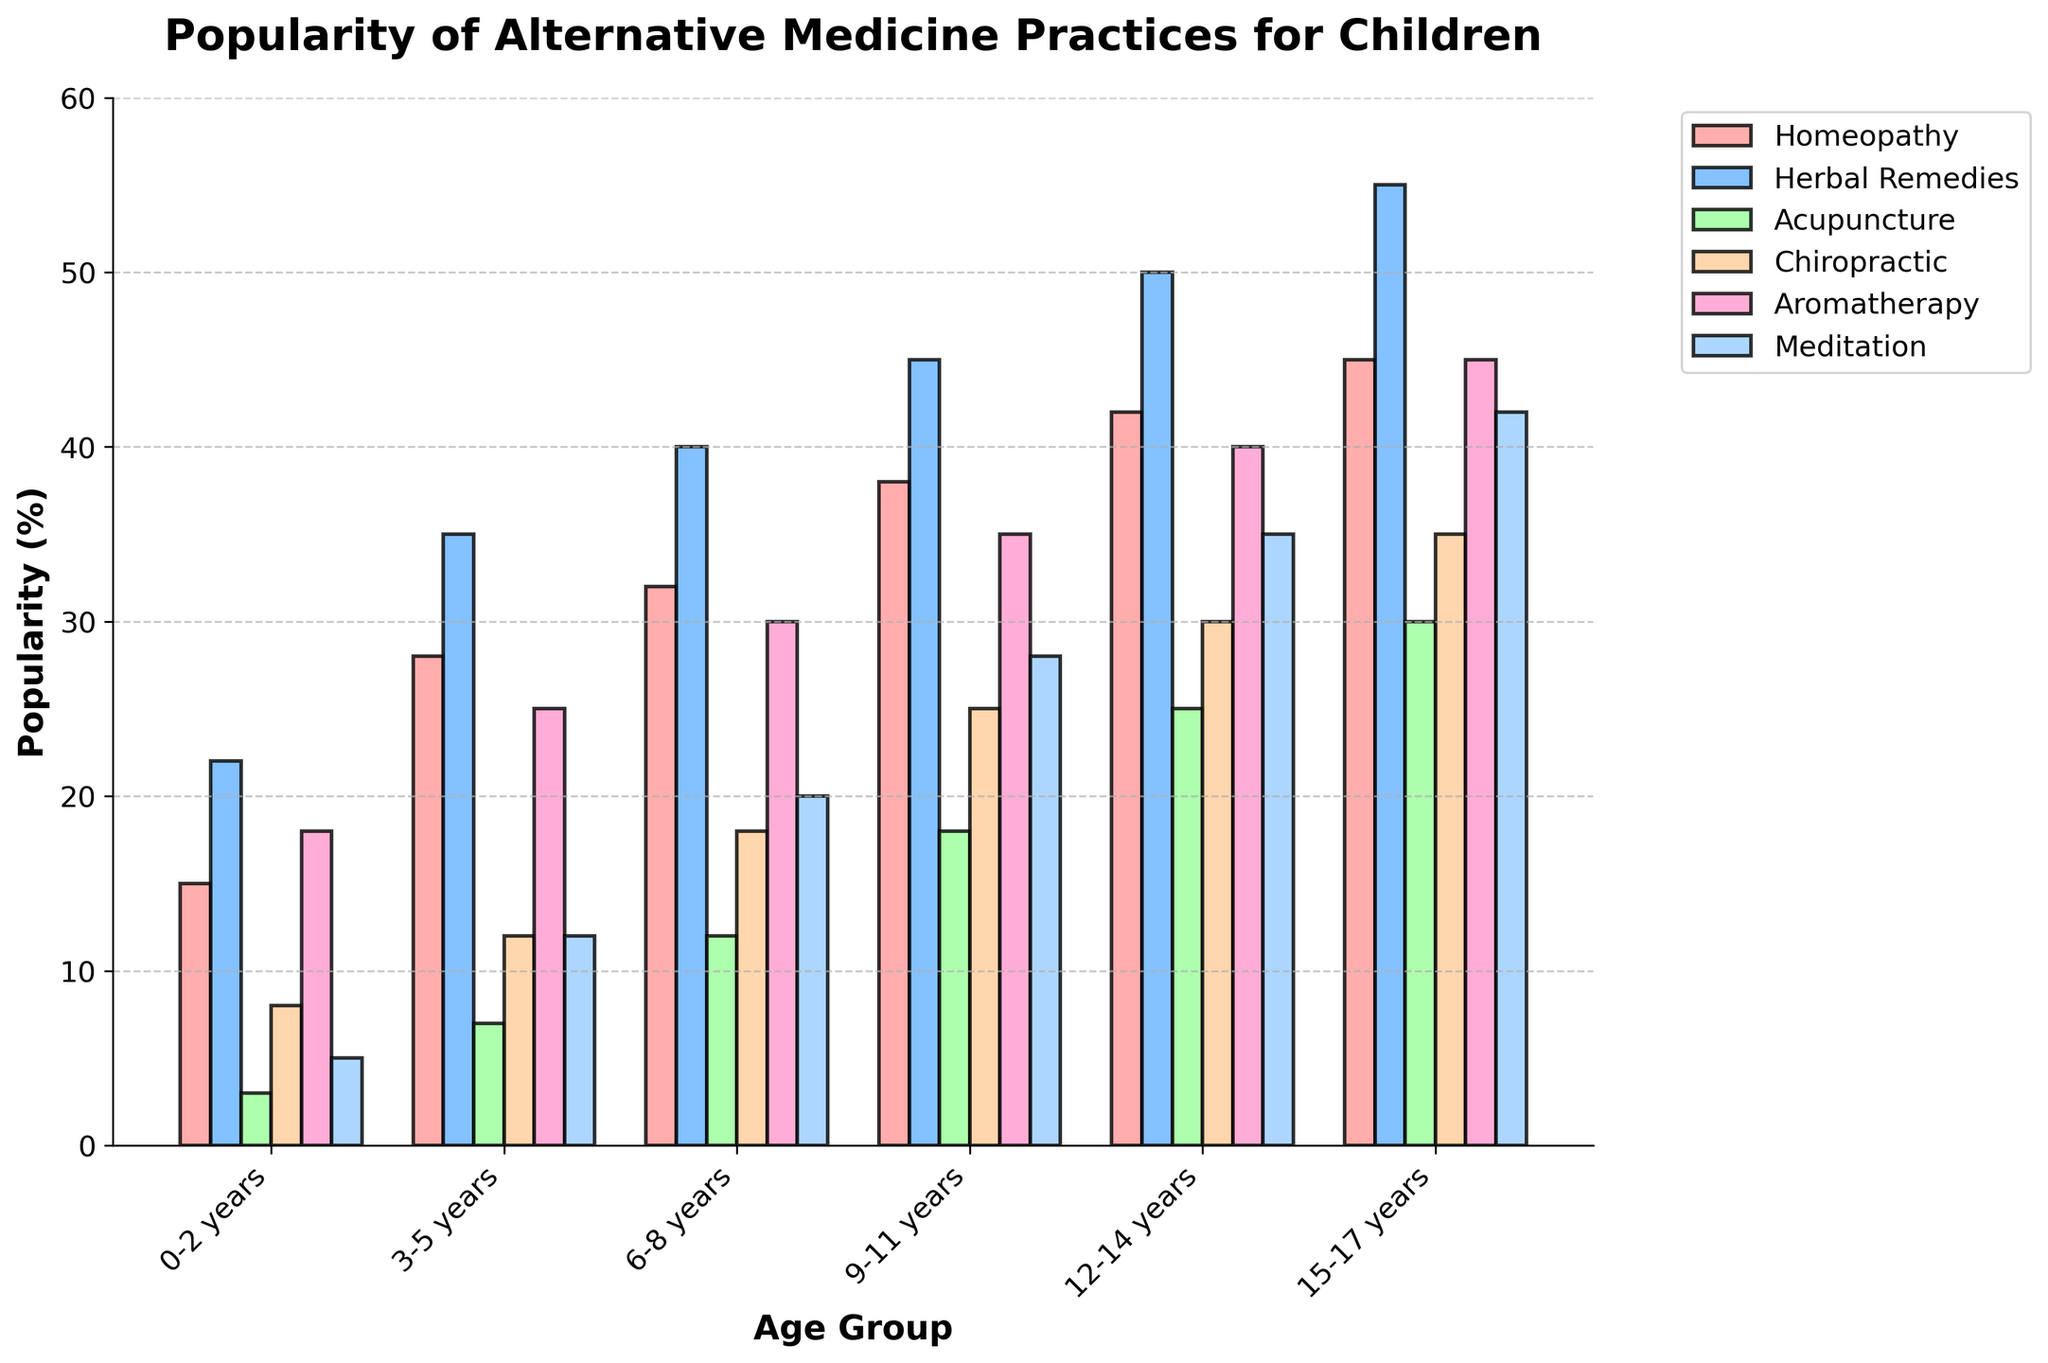Which alternative medicine practice is the most popular for children aged 15-17 years? Look at the height of the bars for the 15-17 years age group. The bar for Herbal Remedies is the highest.
Answer: Herbal Remedies How does the popularity of Acupuncture for children aged 6-8 years compare with those aged 0-2 years? Compare the height of the bars for Acupuncture in the age groups 6-8 years and 0-2 years. The value for 6-8 years is higher than 0-2 years.
Answer: Higher What is the total popularity percentage of Homeopathy and Aromatherapy combined for children aged 9-11 years? Sum the values for Homeopathy and Aromatherapy in the 9-11 years age group. Homeopathy is 38, and Aromatherapy is 35, thus the total is 38 + 35.
Answer: 73% Which age group shows the highest popularity for Meditation? Identify the age group where the bar for Meditation has the maximum height. The 15-17 years age group has the highest bar for Meditation.
Answer: 15-17 years Is the popularity of Chiropractic greater for children aged 12-14 years or 9-11 years? Compare the height of the bars for Chiropractic in the age groups 12-14 years and 9-11 years. The bar for 12-14 years is higher.
Answer: 12-14 years Using the data for the 3-5 years age group, which practice is least popular? Identify the shortest bar among the practices for the 3-5 years age group. The shortest bar is for Acupuncture.
Answer: Acupuncture What is the difference in popularity between Homeopathy and Herbal Remedies for children aged 6-8 years? Subtract the value of Homeopathy from Herbal Remedies in the 6-8 years age group. Herbal Remedies is 40, and Homeopathy is 32, thus the difference is 40 - 32.
Answer: 8% Which two age groups show the most similar popularity for Aromatherapy? Compare the heights of the bars for Aromatherapy across all age groups and find the ones that are closest. The 6-8 years and 9-11 years groups have Aromatherapy values close to each other (30 and 35).
Answer: 6-8 years and 9-11 years What is the overall trend in the popularity of Herbal Remedies from age 0 to 17 years? Observe the pattern of the bar heights for Herbal Remedies across all age groups. The heights are increasing, showing a rising trend.
Answer: Increasing Among all practices, which one shows the highest increase in popularity from 0-2 years to 15-17 years? Calculate the increase for each practice from 0-2 years to 15-17 years and identify the highest. Herbal Remedies increases from 22 to 55, which is the highest increase (55 - 22 = 33).
Answer: Herbal Remedies 